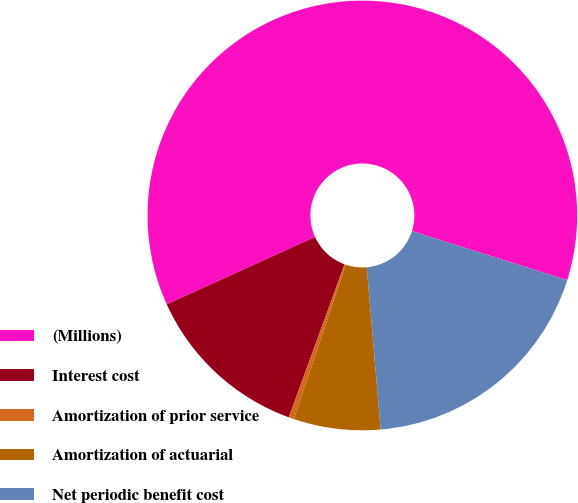Convert chart. <chart><loc_0><loc_0><loc_500><loc_500><pie_chart><fcel>(Millions)<fcel>Interest cost<fcel>Amortization of prior service<fcel>Amortization of actuarial<fcel>Net periodic benefit cost<nl><fcel>61.65%<fcel>12.65%<fcel>0.4%<fcel>6.52%<fcel>18.77%<nl></chart> 